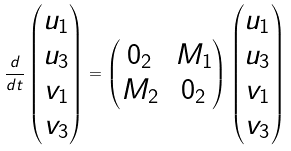Convert formula to latex. <formula><loc_0><loc_0><loc_500><loc_500>\frac { d } { d t } \begin{pmatrix} u _ { 1 } \\ u _ { 3 } \\ v _ { 1 } \\ v _ { 3 } \end{pmatrix} = \begin{pmatrix} 0 _ { 2 } & M _ { 1 } \\ M _ { 2 } & 0 _ { 2 } \end{pmatrix} \begin{pmatrix} u _ { 1 } \\ u _ { 3 } \\ v _ { 1 } \\ v _ { 3 } \end{pmatrix}</formula> 